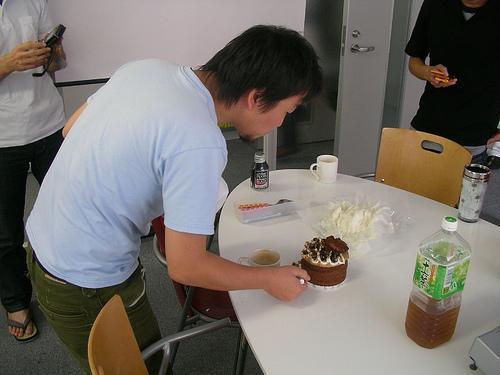About how much liquid is in the bottle with the green label?
Pick the correct solution from the four options below to address the question.
Options: Nine tenths, third, full, none. Third. 